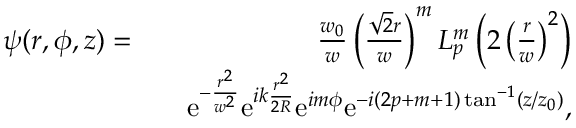Convert formula to latex. <formula><loc_0><loc_0><loc_500><loc_500>\begin{array} { r l r } { \psi ( r , \phi , z ) = } & { \frac { w _ { 0 } } { w } \left ( \frac { \sqrt { 2 } r } { w } \right ) ^ { m } L _ { p } ^ { m } \left ( 2 \left ( \frac { r } { w } \right ) ^ { 2 } \right ) } \\ & { e ^ { - \frac { r ^ { 2 } } { w ^ { 2 } } } e ^ { i k \frac { r ^ { 2 } } { 2 R } } e ^ { i m \phi } e ^ { - i ( 2 p + m + 1 ) \tan ^ { - 1 } ( z / z _ { 0 } ) } , } \end{array}</formula> 